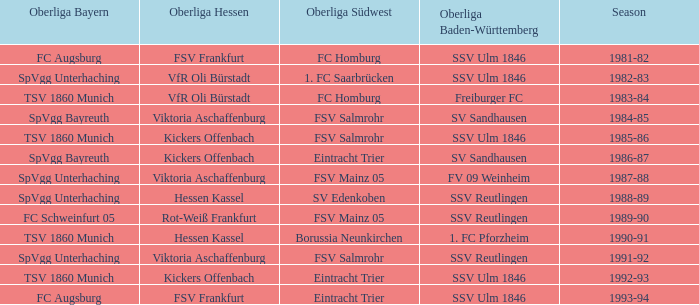Which team was part of the oberliga baden-württemberg during the 1991-92 season? SSV Reutlingen. 